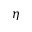Convert formula to latex. <formula><loc_0><loc_0><loc_500><loc_500>\eta</formula> 